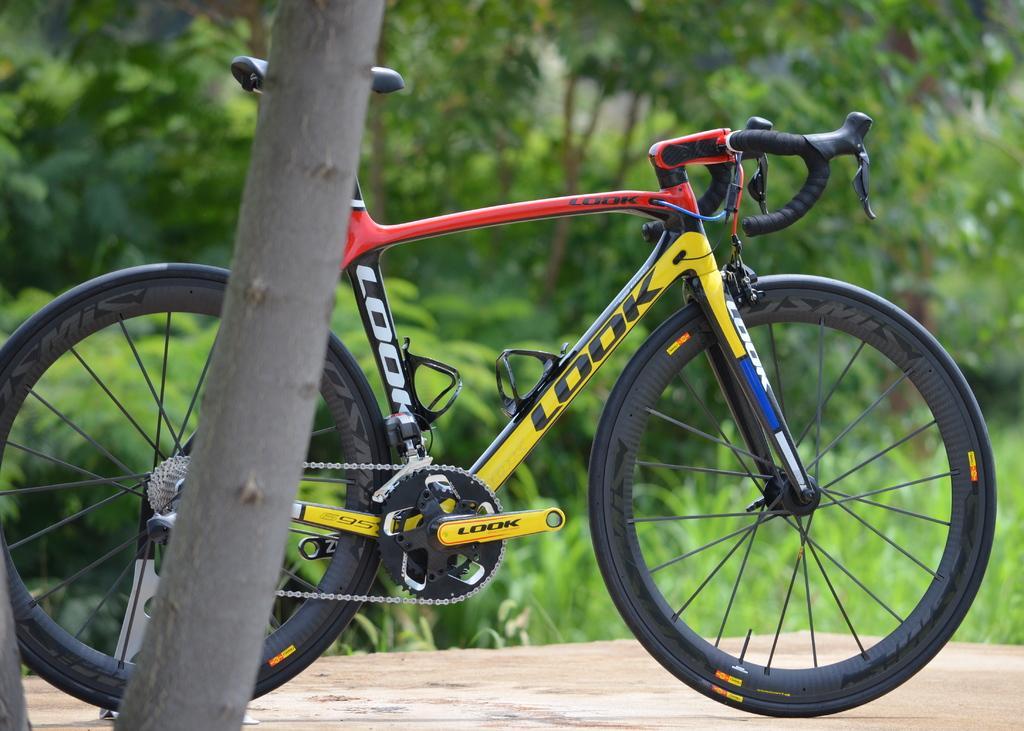Can you describe this image briefly? In this picture there is a bicycle which is parked near to the tree. In the background we can see plants, trees and grass. 